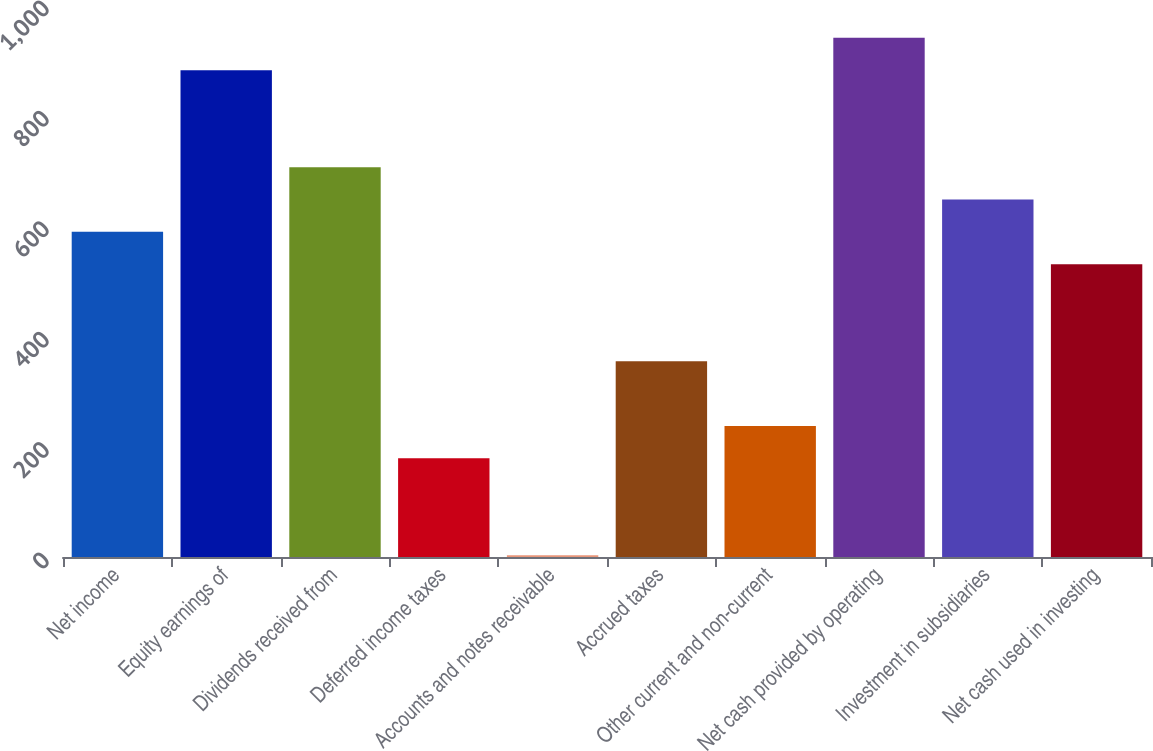Convert chart to OTSL. <chart><loc_0><loc_0><loc_500><loc_500><bar_chart><fcel>Net income<fcel>Equity earnings of<fcel>Dividends received from<fcel>Deferred income taxes<fcel>Accounts and notes receivable<fcel>Accrued taxes<fcel>Other current and non-current<fcel>Net cash provided by operating<fcel>Investment in subsidiaries<fcel>Net cash used in investing<nl><fcel>589<fcel>882<fcel>706.2<fcel>178.8<fcel>3<fcel>354.6<fcel>237.4<fcel>940.6<fcel>647.6<fcel>530.4<nl></chart> 